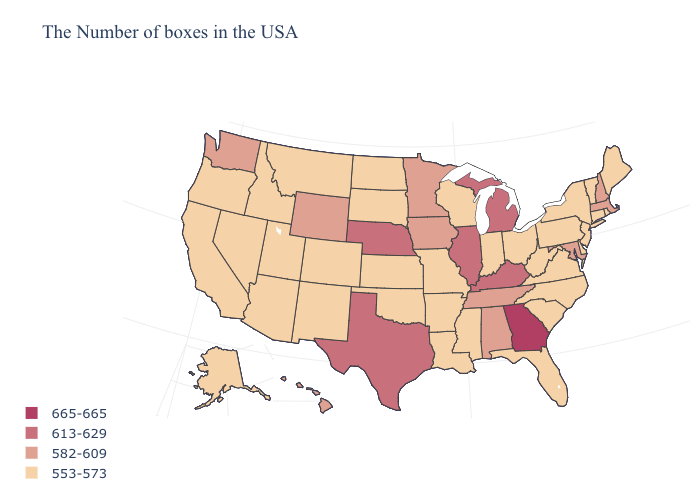Which states have the lowest value in the USA?
Quick response, please. Maine, Rhode Island, Vermont, Connecticut, New York, New Jersey, Delaware, Pennsylvania, Virginia, North Carolina, South Carolina, West Virginia, Ohio, Florida, Indiana, Wisconsin, Mississippi, Louisiana, Missouri, Arkansas, Kansas, Oklahoma, South Dakota, North Dakota, Colorado, New Mexico, Utah, Montana, Arizona, Idaho, Nevada, California, Oregon, Alaska. What is the value of North Carolina?
Answer briefly. 553-573. What is the lowest value in the Northeast?
Quick response, please. 553-573. What is the lowest value in the West?
Keep it brief. 553-573. Name the states that have a value in the range 665-665?
Short answer required. Georgia. Name the states that have a value in the range 553-573?
Write a very short answer. Maine, Rhode Island, Vermont, Connecticut, New York, New Jersey, Delaware, Pennsylvania, Virginia, North Carolina, South Carolina, West Virginia, Ohio, Florida, Indiana, Wisconsin, Mississippi, Louisiana, Missouri, Arkansas, Kansas, Oklahoma, South Dakota, North Dakota, Colorado, New Mexico, Utah, Montana, Arizona, Idaho, Nevada, California, Oregon, Alaska. What is the value of California?
Give a very brief answer. 553-573. What is the value of Delaware?
Be succinct. 553-573. Among the states that border Georgia , does Florida have the lowest value?
Give a very brief answer. Yes. What is the highest value in the USA?
Answer briefly. 665-665. What is the value of Vermont?
Short answer required. 553-573. What is the lowest value in the USA?
Short answer required. 553-573. Is the legend a continuous bar?
Concise answer only. No. Among the states that border Montana , which have the lowest value?
Quick response, please. South Dakota, North Dakota, Idaho. Does the first symbol in the legend represent the smallest category?
Quick response, please. No. 